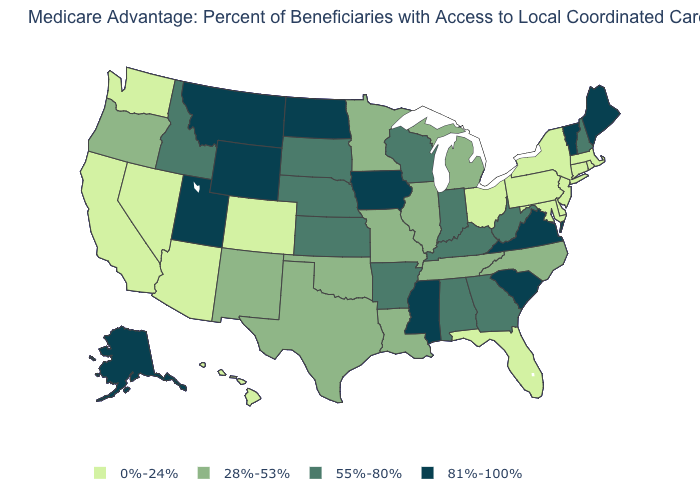Among the states that border Kansas , does Colorado have the highest value?
Keep it brief. No. What is the highest value in the USA?
Answer briefly. 81%-100%. How many symbols are there in the legend?
Quick response, please. 4. What is the value of Wyoming?
Keep it brief. 81%-100%. Name the states that have a value in the range 28%-53%?
Write a very short answer. Illinois, Louisiana, Michigan, Minnesota, Missouri, North Carolina, New Mexico, Oklahoma, Oregon, Tennessee, Texas. Among the states that border Maine , which have the lowest value?
Keep it brief. New Hampshire. Name the states that have a value in the range 81%-100%?
Give a very brief answer. Alaska, Iowa, Maine, Mississippi, Montana, North Dakota, South Carolina, Utah, Virginia, Vermont, Wyoming. Is the legend a continuous bar?
Answer briefly. No. What is the value of Hawaii?
Keep it brief. 0%-24%. Which states have the lowest value in the USA?
Quick response, please. Arizona, California, Colorado, Connecticut, Delaware, Florida, Hawaii, Massachusetts, Maryland, New Jersey, Nevada, New York, Ohio, Pennsylvania, Rhode Island, Washington. What is the lowest value in the South?
Write a very short answer. 0%-24%. What is the value of Virginia?
Answer briefly. 81%-100%. What is the highest value in the USA?
Concise answer only. 81%-100%. Among the states that border Rhode Island , which have the highest value?
Give a very brief answer. Connecticut, Massachusetts. Which states have the lowest value in the Northeast?
Answer briefly. Connecticut, Massachusetts, New Jersey, New York, Pennsylvania, Rhode Island. 